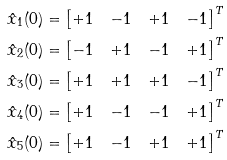<formula> <loc_0><loc_0><loc_500><loc_500>\hat { x } _ { 1 } ( 0 ) & = \begin{bmatrix} + 1 & - 1 & + 1 & - 1 \end{bmatrix} ^ { T } \\ \hat { x } _ { 2 } ( 0 ) & = \begin{bmatrix} - 1 & + 1 & - 1 & + 1 \end{bmatrix} ^ { T } \\ \hat { x } _ { 3 } ( 0 ) & = \begin{bmatrix} + 1 & + 1 & + 1 & - 1 \end{bmatrix} ^ { T } \\ \hat { x } _ { 4 } ( 0 ) & = \begin{bmatrix} + 1 & - 1 & - 1 & + 1 \end{bmatrix} ^ { T } \\ \hat { x } _ { 5 } ( 0 ) & = \begin{bmatrix} + 1 & - 1 & + 1 & + 1 \end{bmatrix} ^ { T }</formula> 